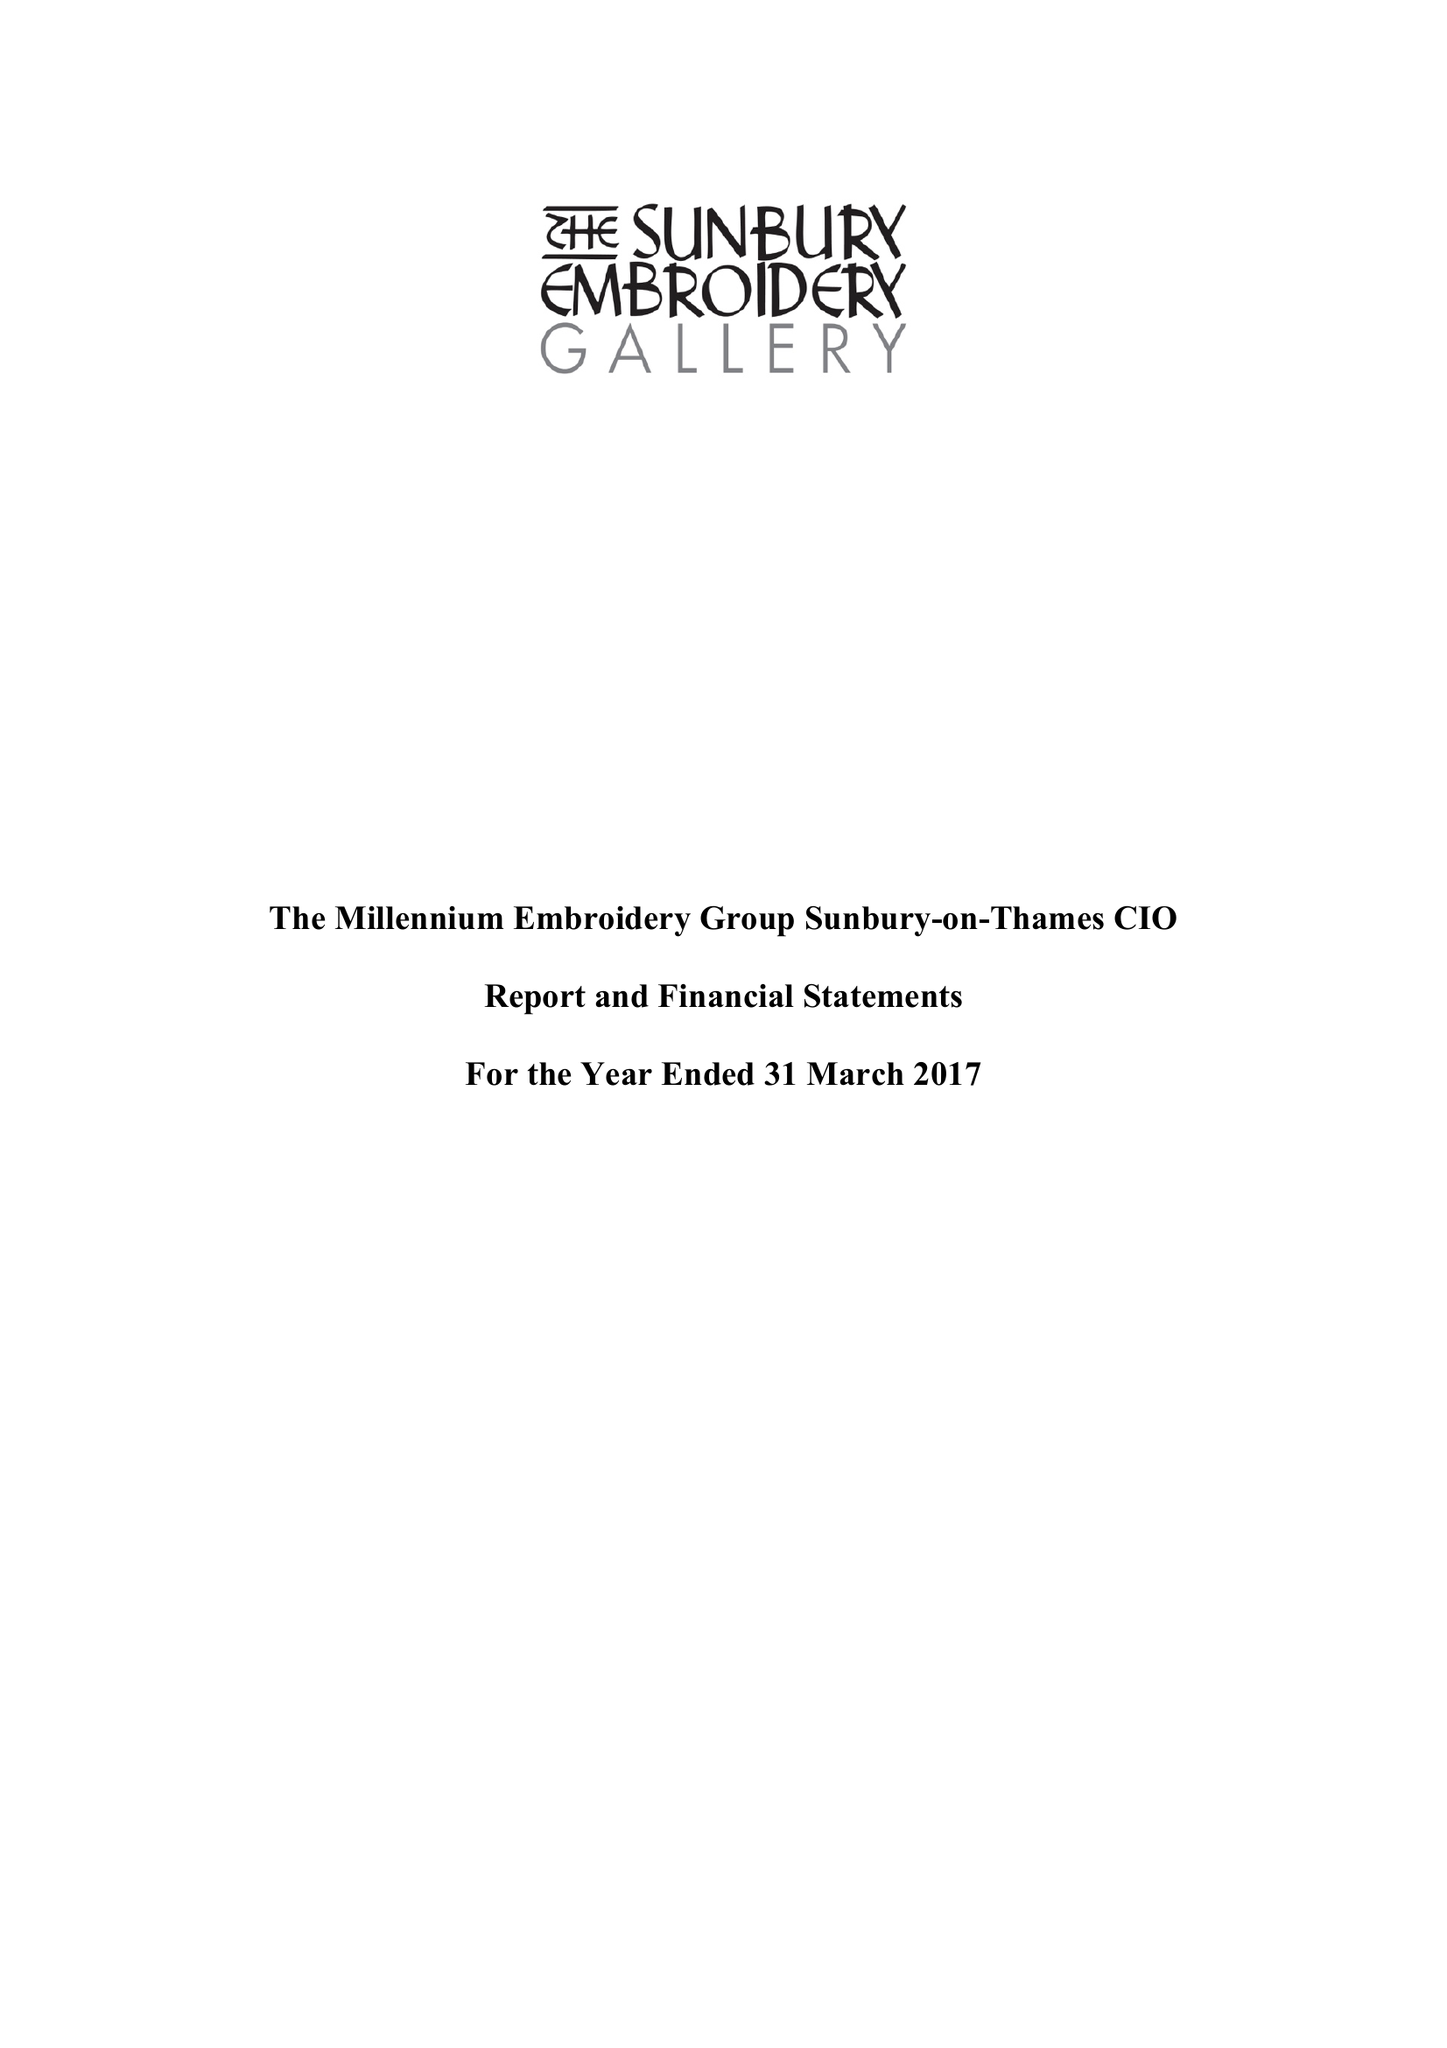What is the value for the charity_name?
Answer the question using a single word or phrase. The Millennium Embroidery Group Sunbury-On-Thames 